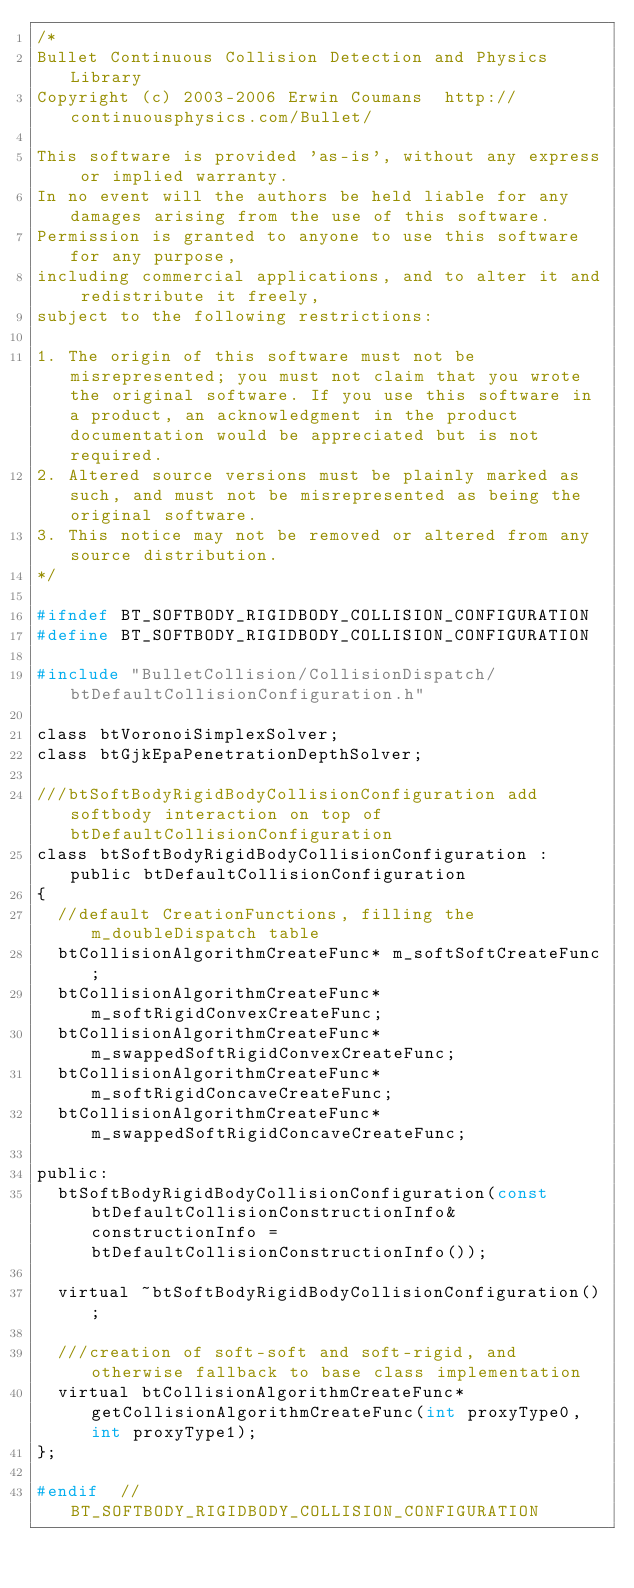Convert code to text. <code><loc_0><loc_0><loc_500><loc_500><_C_>/*
Bullet Continuous Collision Detection and Physics Library
Copyright (c) 2003-2006 Erwin Coumans  http://continuousphysics.com/Bullet/

This software is provided 'as-is', without any express or implied warranty.
In no event will the authors be held liable for any damages arising from the use of this software.
Permission is granted to anyone to use this software for any purpose, 
including commercial applications, and to alter it and redistribute it freely, 
subject to the following restrictions:

1. The origin of this software must not be misrepresented; you must not claim that you wrote the original software. If you use this software in a product, an acknowledgment in the product documentation would be appreciated but is not required.
2. Altered source versions must be plainly marked as such, and must not be misrepresented as being the original software.
3. This notice may not be removed or altered from any source distribution.
*/

#ifndef BT_SOFTBODY_RIGIDBODY_COLLISION_CONFIGURATION
#define BT_SOFTBODY_RIGIDBODY_COLLISION_CONFIGURATION

#include "BulletCollision/CollisionDispatch/btDefaultCollisionConfiguration.h"

class btVoronoiSimplexSolver;
class btGjkEpaPenetrationDepthSolver;

///btSoftBodyRigidBodyCollisionConfiguration add softbody interaction on top of btDefaultCollisionConfiguration
class btSoftBodyRigidBodyCollisionConfiguration : public btDefaultCollisionConfiguration
{
	//default CreationFunctions, filling the m_doubleDispatch table
	btCollisionAlgorithmCreateFunc* m_softSoftCreateFunc;
	btCollisionAlgorithmCreateFunc* m_softRigidConvexCreateFunc;
	btCollisionAlgorithmCreateFunc* m_swappedSoftRigidConvexCreateFunc;
	btCollisionAlgorithmCreateFunc* m_softRigidConcaveCreateFunc;
	btCollisionAlgorithmCreateFunc* m_swappedSoftRigidConcaveCreateFunc;

public:
	btSoftBodyRigidBodyCollisionConfiguration(const btDefaultCollisionConstructionInfo& constructionInfo = btDefaultCollisionConstructionInfo());

	virtual ~btSoftBodyRigidBodyCollisionConfiguration();

	///creation of soft-soft and soft-rigid, and otherwise fallback to base class implementation
	virtual btCollisionAlgorithmCreateFunc* getCollisionAlgorithmCreateFunc(int proxyType0, int proxyType1);
};

#endif  //BT_SOFTBODY_RIGIDBODY_COLLISION_CONFIGURATION
</code> 